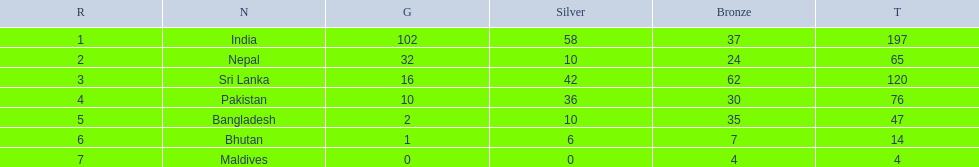What nations took part in 1999 south asian games? India, Nepal, Sri Lanka, Pakistan, Bangladesh, Bhutan, Maldives. Of those who earned gold medals? India, Nepal, Sri Lanka, Pakistan, Bangladesh, Bhutan. Which nation didn't earn any gold medals? Maldives. 